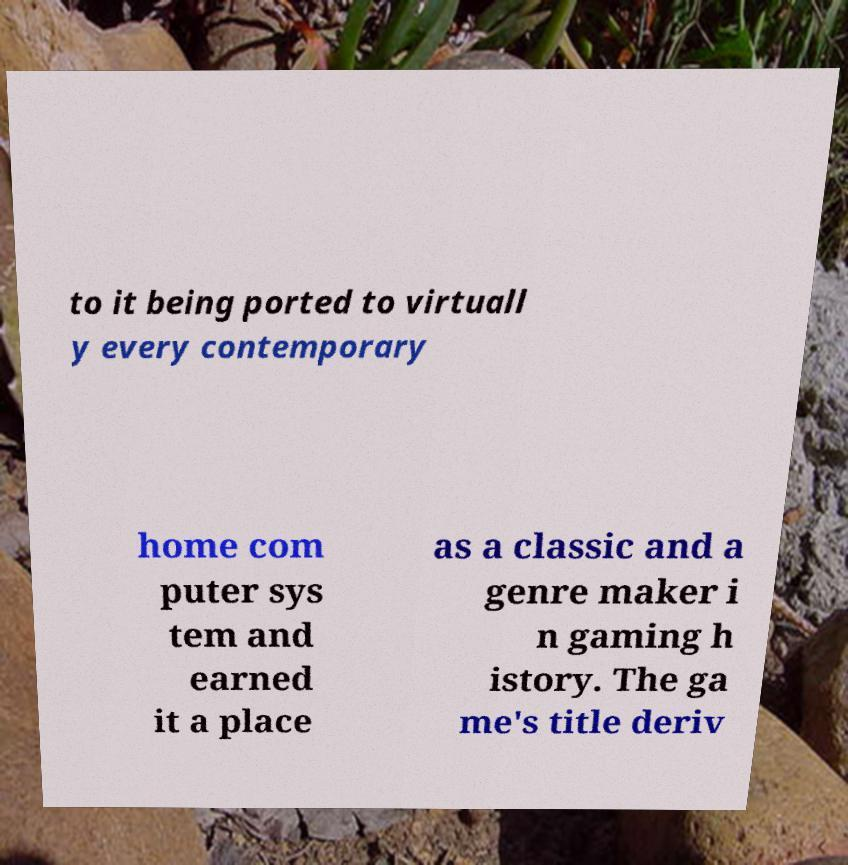Can you read and provide the text displayed in the image?This photo seems to have some interesting text. Can you extract and type it out for me? to it being ported to virtuall y every contemporary home com puter sys tem and earned it a place as a classic and a genre maker i n gaming h istory. The ga me's title deriv 